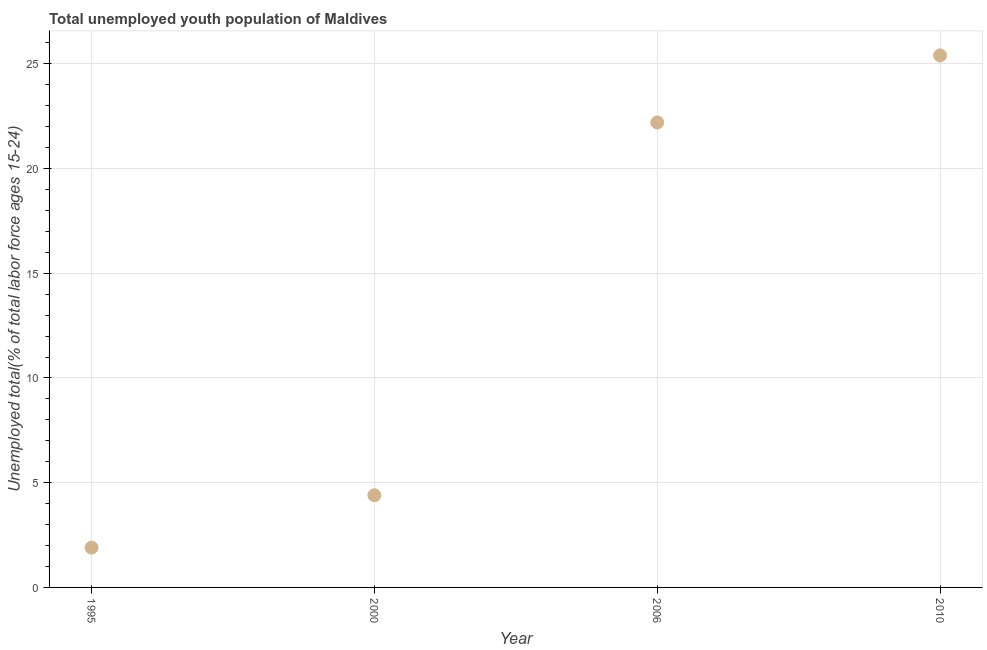What is the unemployed youth in 2006?
Keep it short and to the point. 22.2. Across all years, what is the maximum unemployed youth?
Give a very brief answer. 25.4. Across all years, what is the minimum unemployed youth?
Keep it short and to the point. 1.9. What is the sum of the unemployed youth?
Your response must be concise. 53.9. What is the difference between the unemployed youth in 1995 and 2006?
Your answer should be compact. -20.3. What is the average unemployed youth per year?
Ensure brevity in your answer.  13.48. What is the median unemployed youth?
Provide a short and direct response. 13.3. In how many years, is the unemployed youth greater than 8 %?
Your response must be concise. 2. Do a majority of the years between 2010 and 2000 (inclusive) have unemployed youth greater than 3 %?
Give a very brief answer. No. What is the ratio of the unemployed youth in 1995 to that in 2006?
Offer a terse response. 0.09. What is the difference between the highest and the second highest unemployed youth?
Provide a short and direct response. 3.2. Is the sum of the unemployed youth in 1995 and 2010 greater than the maximum unemployed youth across all years?
Your answer should be very brief. Yes. What is the difference between the highest and the lowest unemployed youth?
Ensure brevity in your answer.  23.5. In how many years, is the unemployed youth greater than the average unemployed youth taken over all years?
Give a very brief answer. 2. How many dotlines are there?
Your answer should be compact. 1. Does the graph contain any zero values?
Keep it short and to the point. No. Does the graph contain grids?
Give a very brief answer. Yes. What is the title of the graph?
Give a very brief answer. Total unemployed youth population of Maldives. What is the label or title of the Y-axis?
Your answer should be compact. Unemployed total(% of total labor force ages 15-24). What is the Unemployed total(% of total labor force ages 15-24) in 1995?
Give a very brief answer. 1.9. What is the Unemployed total(% of total labor force ages 15-24) in 2000?
Give a very brief answer. 4.4. What is the Unemployed total(% of total labor force ages 15-24) in 2006?
Your response must be concise. 22.2. What is the Unemployed total(% of total labor force ages 15-24) in 2010?
Give a very brief answer. 25.4. What is the difference between the Unemployed total(% of total labor force ages 15-24) in 1995 and 2000?
Offer a terse response. -2.5. What is the difference between the Unemployed total(% of total labor force ages 15-24) in 1995 and 2006?
Provide a short and direct response. -20.3. What is the difference between the Unemployed total(% of total labor force ages 15-24) in 1995 and 2010?
Offer a very short reply. -23.5. What is the difference between the Unemployed total(% of total labor force ages 15-24) in 2000 and 2006?
Ensure brevity in your answer.  -17.8. What is the difference between the Unemployed total(% of total labor force ages 15-24) in 2000 and 2010?
Make the answer very short. -21. What is the difference between the Unemployed total(% of total labor force ages 15-24) in 2006 and 2010?
Keep it short and to the point. -3.2. What is the ratio of the Unemployed total(% of total labor force ages 15-24) in 1995 to that in 2000?
Your answer should be very brief. 0.43. What is the ratio of the Unemployed total(% of total labor force ages 15-24) in 1995 to that in 2006?
Ensure brevity in your answer.  0.09. What is the ratio of the Unemployed total(% of total labor force ages 15-24) in 1995 to that in 2010?
Give a very brief answer. 0.07. What is the ratio of the Unemployed total(% of total labor force ages 15-24) in 2000 to that in 2006?
Provide a succinct answer. 0.2. What is the ratio of the Unemployed total(% of total labor force ages 15-24) in 2000 to that in 2010?
Your answer should be very brief. 0.17. What is the ratio of the Unemployed total(% of total labor force ages 15-24) in 2006 to that in 2010?
Make the answer very short. 0.87. 